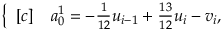Convert formula to latex. <formula><loc_0><loc_0><loc_500><loc_500>\begin{array} { r } { \left \{ \begin{array} { r l } { [ c ] } & a _ { 0 } ^ { 1 } = - \frac { 1 } { 1 2 } u _ { i - 1 } + \frac { 1 3 } { 1 2 } u _ { i } - v _ { i } , } \end{array} } \end{array}</formula> 